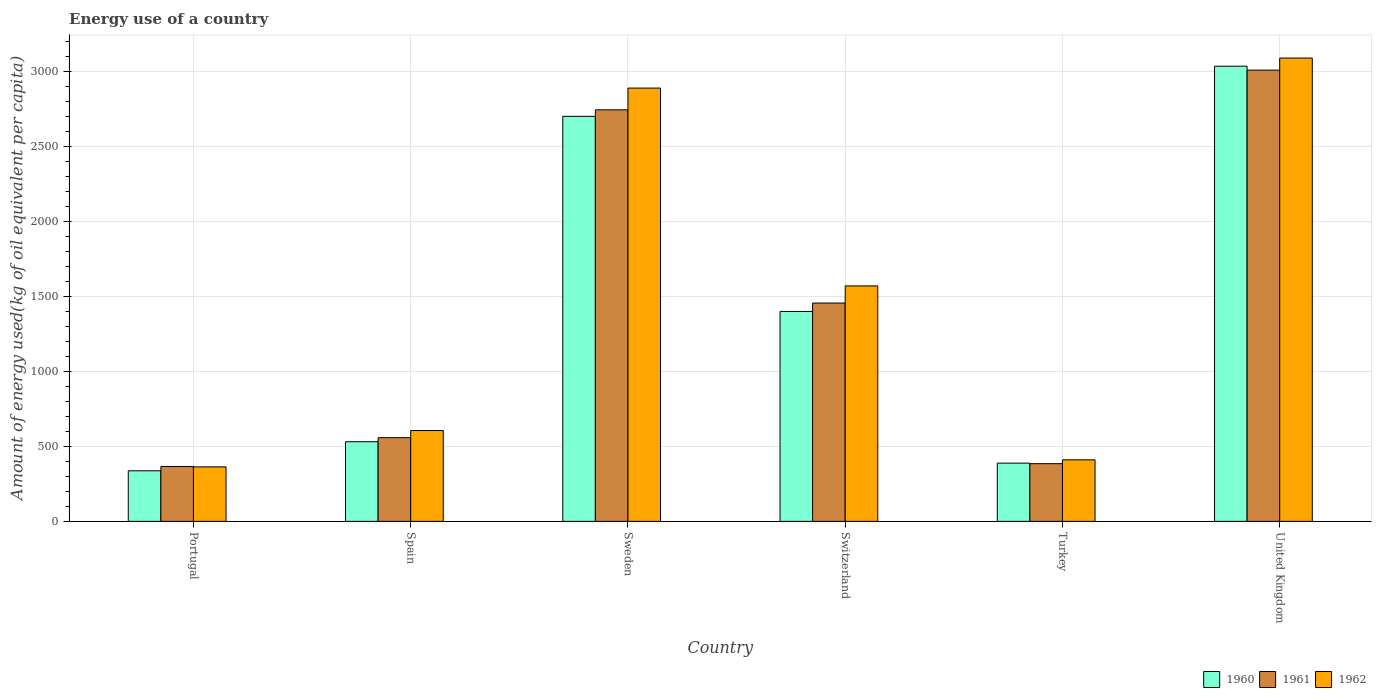How many different coloured bars are there?
Offer a very short reply. 3. How many groups of bars are there?
Your answer should be compact. 6. Are the number of bars on each tick of the X-axis equal?
Provide a succinct answer. Yes. What is the amount of energy used in in 1960 in Switzerland?
Provide a short and direct response. 1398.65. Across all countries, what is the maximum amount of energy used in in 1960?
Give a very brief answer. 3033.05. Across all countries, what is the minimum amount of energy used in in 1961?
Make the answer very short. 365.84. In which country was the amount of energy used in in 1960 maximum?
Your answer should be compact. United Kingdom. What is the total amount of energy used in in 1960 in the graph?
Offer a terse response. 8386.05. What is the difference between the amount of energy used in in 1962 in Spain and that in Switzerland?
Keep it short and to the point. -963.69. What is the difference between the amount of energy used in in 1960 in Switzerland and the amount of energy used in in 1961 in Sweden?
Ensure brevity in your answer.  -1343.47. What is the average amount of energy used in in 1961 per country?
Your response must be concise. 1418.57. What is the difference between the amount of energy used in of/in 1961 and amount of energy used in of/in 1960 in United Kingdom?
Provide a succinct answer. -26.3. In how many countries, is the amount of energy used in in 1960 greater than 100 kg?
Offer a terse response. 6. What is the ratio of the amount of energy used in in 1960 in Switzerland to that in United Kingdom?
Ensure brevity in your answer.  0.46. Is the amount of energy used in in 1961 in Spain less than that in Switzerland?
Provide a short and direct response. Yes. Is the difference between the amount of energy used in in 1961 in Spain and Switzerland greater than the difference between the amount of energy used in in 1960 in Spain and Switzerland?
Ensure brevity in your answer.  No. What is the difference between the highest and the second highest amount of energy used in in 1961?
Offer a terse response. -264.62. What is the difference between the highest and the lowest amount of energy used in in 1960?
Make the answer very short. 2696.14. How many bars are there?
Provide a short and direct response. 18. Are all the bars in the graph horizontal?
Your answer should be very brief. No. What is the difference between two consecutive major ticks on the Y-axis?
Provide a succinct answer. 500. Does the graph contain grids?
Make the answer very short. Yes. How many legend labels are there?
Offer a very short reply. 3. How are the legend labels stacked?
Provide a succinct answer. Horizontal. What is the title of the graph?
Ensure brevity in your answer.  Energy use of a country. What is the label or title of the X-axis?
Your answer should be compact. Country. What is the label or title of the Y-axis?
Make the answer very short. Amount of energy used(kg of oil equivalent per capita). What is the Amount of energy used(kg of oil equivalent per capita) in 1960 in Portugal?
Offer a very short reply. 336.91. What is the Amount of energy used(kg of oil equivalent per capita) in 1961 in Portugal?
Your response must be concise. 365.84. What is the Amount of energy used(kg of oil equivalent per capita) of 1962 in Portugal?
Your answer should be compact. 363.16. What is the Amount of energy used(kg of oil equivalent per capita) in 1960 in Spain?
Give a very brief answer. 530.66. What is the Amount of energy used(kg of oil equivalent per capita) of 1961 in Spain?
Keep it short and to the point. 557.6. What is the Amount of energy used(kg of oil equivalent per capita) in 1962 in Spain?
Provide a succinct answer. 605.22. What is the Amount of energy used(kg of oil equivalent per capita) of 1960 in Sweden?
Your answer should be compact. 2698.79. What is the Amount of energy used(kg of oil equivalent per capita) of 1961 in Sweden?
Your answer should be very brief. 2742.12. What is the Amount of energy used(kg of oil equivalent per capita) in 1962 in Sweden?
Give a very brief answer. 2887.24. What is the Amount of energy used(kg of oil equivalent per capita) in 1960 in Switzerland?
Ensure brevity in your answer.  1398.65. What is the Amount of energy used(kg of oil equivalent per capita) of 1961 in Switzerland?
Ensure brevity in your answer.  1454.76. What is the Amount of energy used(kg of oil equivalent per capita) of 1962 in Switzerland?
Offer a terse response. 1568.91. What is the Amount of energy used(kg of oil equivalent per capita) of 1960 in Turkey?
Ensure brevity in your answer.  387.97. What is the Amount of energy used(kg of oil equivalent per capita) in 1961 in Turkey?
Offer a terse response. 384.35. What is the Amount of energy used(kg of oil equivalent per capita) in 1962 in Turkey?
Offer a very short reply. 410.02. What is the Amount of energy used(kg of oil equivalent per capita) in 1960 in United Kingdom?
Your answer should be compact. 3033.05. What is the Amount of energy used(kg of oil equivalent per capita) of 1961 in United Kingdom?
Make the answer very short. 3006.75. What is the Amount of energy used(kg of oil equivalent per capita) in 1962 in United Kingdom?
Offer a terse response. 3087.34. Across all countries, what is the maximum Amount of energy used(kg of oil equivalent per capita) of 1960?
Keep it short and to the point. 3033.05. Across all countries, what is the maximum Amount of energy used(kg of oil equivalent per capita) in 1961?
Your answer should be very brief. 3006.75. Across all countries, what is the maximum Amount of energy used(kg of oil equivalent per capita) in 1962?
Give a very brief answer. 3087.34. Across all countries, what is the minimum Amount of energy used(kg of oil equivalent per capita) of 1960?
Provide a succinct answer. 336.91. Across all countries, what is the minimum Amount of energy used(kg of oil equivalent per capita) of 1961?
Provide a succinct answer. 365.84. Across all countries, what is the minimum Amount of energy used(kg of oil equivalent per capita) in 1962?
Your response must be concise. 363.16. What is the total Amount of energy used(kg of oil equivalent per capita) of 1960 in the graph?
Your answer should be very brief. 8386.05. What is the total Amount of energy used(kg of oil equivalent per capita) in 1961 in the graph?
Your answer should be very brief. 8511.41. What is the total Amount of energy used(kg of oil equivalent per capita) of 1962 in the graph?
Make the answer very short. 8921.9. What is the difference between the Amount of energy used(kg of oil equivalent per capita) of 1960 in Portugal and that in Spain?
Provide a succinct answer. -193.75. What is the difference between the Amount of energy used(kg of oil equivalent per capita) in 1961 in Portugal and that in Spain?
Your answer should be compact. -191.76. What is the difference between the Amount of energy used(kg of oil equivalent per capita) of 1962 in Portugal and that in Spain?
Make the answer very short. -242.06. What is the difference between the Amount of energy used(kg of oil equivalent per capita) of 1960 in Portugal and that in Sweden?
Give a very brief answer. -2361.88. What is the difference between the Amount of energy used(kg of oil equivalent per capita) of 1961 in Portugal and that in Sweden?
Ensure brevity in your answer.  -2376.28. What is the difference between the Amount of energy used(kg of oil equivalent per capita) of 1962 in Portugal and that in Sweden?
Ensure brevity in your answer.  -2524.07. What is the difference between the Amount of energy used(kg of oil equivalent per capita) in 1960 in Portugal and that in Switzerland?
Provide a short and direct response. -1061.74. What is the difference between the Amount of energy used(kg of oil equivalent per capita) in 1961 in Portugal and that in Switzerland?
Offer a very short reply. -1088.91. What is the difference between the Amount of energy used(kg of oil equivalent per capita) in 1962 in Portugal and that in Switzerland?
Your answer should be compact. -1205.75. What is the difference between the Amount of energy used(kg of oil equivalent per capita) in 1960 in Portugal and that in Turkey?
Provide a short and direct response. -51.06. What is the difference between the Amount of energy used(kg of oil equivalent per capita) of 1961 in Portugal and that in Turkey?
Offer a terse response. -18.51. What is the difference between the Amount of energy used(kg of oil equivalent per capita) of 1962 in Portugal and that in Turkey?
Offer a very short reply. -46.86. What is the difference between the Amount of energy used(kg of oil equivalent per capita) of 1960 in Portugal and that in United Kingdom?
Offer a very short reply. -2696.14. What is the difference between the Amount of energy used(kg of oil equivalent per capita) in 1961 in Portugal and that in United Kingdom?
Keep it short and to the point. -2640.91. What is the difference between the Amount of energy used(kg of oil equivalent per capita) in 1962 in Portugal and that in United Kingdom?
Give a very brief answer. -2724.18. What is the difference between the Amount of energy used(kg of oil equivalent per capita) in 1960 in Spain and that in Sweden?
Keep it short and to the point. -2168.13. What is the difference between the Amount of energy used(kg of oil equivalent per capita) of 1961 in Spain and that in Sweden?
Ensure brevity in your answer.  -2184.52. What is the difference between the Amount of energy used(kg of oil equivalent per capita) of 1962 in Spain and that in Sweden?
Provide a short and direct response. -2282.01. What is the difference between the Amount of energy used(kg of oil equivalent per capita) in 1960 in Spain and that in Switzerland?
Your response must be concise. -867.99. What is the difference between the Amount of energy used(kg of oil equivalent per capita) in 1961 in Spain and that in Switzerland?
Provide a succinct answer. -897.16. What is the difference between the Amount of energy used(kg of oil equivalent per capita) of 1962 in Spain and that in Switzerland?
Give a very brief answer. -963.69. What is the difference between the Amount of energy used(kg of oil equivalent per capita) in 1960 in Spain and that in Turkey?
Keep it short and to the point. 142.69. What is the difference between the Amount of energy used(kg of oil equivalent per capita) in 1961 in Spain and that in Turkey?
Your response must be concise. 173.25. What is the difference between the Amount of energy used(kg of oil equivalent per capita) in 1962 in Spain and that in Turkey?
Provide a succinct answer. 195.2. What is the difference between the Amount of energy used(kg of oil equivalent per capita) in 1960 in Spain and that in United Kingdom?
Provide a short and direct response. -2502.39. What is the difference between the Amount of energy used(kg of oil equivalent per capita) of 1961 in Spain and that in United Kingdom?
Your answer should be compact. -2449.15. What is the difference between the Amount of energy used(kg of oil equivalent per capita) of 1962 in Spain and that in United Kingdom?
Ensure brevity in your answer.  -2482.12. What is the difference between the Amount of energy used(kg of oil equivalent per capita) in 1960 in Sweden and that in Switzerland?
Make the answer very short. 1300.14. What is the difference between the Amount of energy used(kg of oil equivalent per capita) in 1961 in Sweden and that in Switzerland?
Your answer should be very brief. 1287.37. What is the difference between the Amount of energy used(kg of oil equivalent per capita) of 1962 in Sweden and that in Switzerland?
Ensure brevity in your answer.  1318.33. What is the difference between the Amount of energy used(kg of oil equivalent per capita) of 1960 in Sweden and that in Turkey?
Your answer should be compact. 2310.82. What is the difference between the Amount of energy used(kg of oil equivalent per capita) in 1961 in Sweden and that in Turkey?
Provide a succinct answer. 2357.78. What is the difference between the Amount of energy used(kg of oil equivalent per capita) in 1962 in Sweden and that in Turkey?
Your response must be concise. 2477.21. What is the difference between the Amount of energy used(kg of oil equivalent per capita) of 1960 in Sweden and that in United Kingdom?
Your answer should be very brief. -334.26. What is the difference between the Amount of energy used(kg of oil equivalent per capita) of 1961 in Sweden and that in United Kingdom?
Your answer should be compact. -264.62. What is the difference between the Amount of energy used(kg of oil equivalent per capita) in 1962 in Sweden and that in United Kingdom?
Your response must be concise. -200.11. What is the difference between the Amount of energy used(kg of oil equivalent per capita) of 1960 in Switzerland and that in Turkey?
Provide a succinct answer. 1010.68. What is the difference between the Amount of energy used(kg of oil equivalent per capita) in 1961 in Switzerland and that in Turkey?
Offer a terse response. 1070.41. What is the difference between the Amount of energy used(kg of oil equivalent per capita) of 1962 in Switzerland and that in Turkey?
Offer a very short reply. 1158.89. What is the difference between the Amount of energy used(kg of oil equivalent per capita) in 1960 in Switzerland and that in United Kingdom?
Ensure brevity in your answer.  -1634.4. What is the difference between the Amount of energy used(kg of oil equivalent per capita) in 1961 in Switzerland and that in United Kingdom?
Provide a short and direct response. -1551.99. What is the difference between the Amount of energy used(kg of oil equivalent per capita) of 1962 in Switzerland and that in United Kingdom?
Ensure brevity in your answer.  -1518.43. What is the difference between the Amount of energy used(kg of oil equivalent per capita) of 1960 in Turkey and that in United Kingdom?
Make the answer very short. -2645.08. What is the difference between the Amount of energy used(kg of oil equivalent per capita) of 1961 in Turkey and that in United Kingdom?
Provide a succinct answer. -2622.4. What is the difference between the Amount of energy used(kg of oil equivalent per capita) of 1962 in Turkey and that in United Kingdom?
Provide a short and direct response. -2677.32. What is the difference between the Amount of energy used(kg of oil equivalent per capita) in 1960 in Portugal and the Amount of energy used(kg of oil equivalent per capita) in 1961 in Spain?
Keep it short and to the point. -220.69. What is the difference between the Amount of energy used(kg of oil equivalent per capita) in 1960 in Portugal and the Amount of energy used(kg of oil equivalent per capita) in 1962 in Spain?
Ensure brevity in your answer.  -268.31. What is the difference between the Amount of energy used(kg of oil equivalent per capita) in 1961 in Portugal and the Amount of energy used(kg of oil equivalent per capita) in 1962 in Spain?
Ensure brevity in your answer.  -239.38. What is the difference between the Amount of energy used(kg of oil equivalent per capita) in 1960 in Portugal and the Amount of energy used(kg of oil equivalent per capita) in 1961 in Sweden?
Keep it short and to the point. -2405.21. What is the difference between the Amount of energy used(kg of oil equivalent per capita) in 1960 in Portugal and the Amount of energy used(kg of oil equivalent per capita) in 1962 in Sweden?
Keep it short and to the point. -2550.32. What is the difference between the Amount of energy used(kg of oil equivalent per capita) of 1961 in Portugal and the Amount of energy used(kg of oil equivalent per capita) of 1962 in Sweden?
Provide a short and direct response. -2521.4. What is the difference between the Amount of energy used(kg of oil equivalent per capita) in 1960 in Portugal and the Amount of energy used(kg of oil equivalent per capita) in 1961 in Switzerland?
Provide a succinct answer. -1117.84. What is the difference between the Amount of energy used(kg of oil equivalent per capita) in 1960 in Portugal and the Amount of energy used(kg of oil equivalent per capita) in 1962 in Switzerland?
Give a very brief answer. -1232. What is the difference between the Amount of energy used(kg of oil equivalent per capita) in 1961 in Portugal and the Amount of energy used(kg of oil equivalent per capita) in 1962 in Switzerland?
Ensure brevity in your answer.  -1203.07. What is the difference between the Amount of energy used(kg of oil equivalent per capita) of 1960 in Portugal and the Amount of energy used(kg of oil equivalent per capita) of 1961 in Turkey?
Offer a very short reply. -47.43. What is the difference between the Amount of energy used(kg of oil equivalent per capita) of 1960 in Portugal and the Amount of energy used(kg of oil equivalent per capita) of 1962 in Turkey?
Ensure brevity in your answer.  -73.11. What is the difference between the Amount of energy used(kg of oil equivalent per capita) in 1961 in Portugal and the Amount of energy used(kg of oil equivalent per capita) in 1962 in Turkey?
Provide a short and direct response. -44.18. What is the difference between the Amount of energy used(kg of oil equivalent per capita) in 1960 in Portugal and the Amount of energy used(kg of oil equivalent per capita) in 1961 in United Kingdom?
Provide a succinct answer. -2669.83. What is the difference between the Amount of energy used(kg of oil equivalent per capita) of 1960 in Portugal and the Amount of energy used(kg of oil equivalent per capita) of 1962 in United Kingdom?
Provide a short and direct response. -2750.43. What is the difference between the Amount of energy used(kg of oil equivalent per capita) in 1961 in Portugal and the Amount of energy used(kg of oil equivalent per capita) in 1962 in United Kingdom?
Provide a succinct answer. -2721.5. What is the difference between the Amount of energy used(kg of oil equivalent per capita) of 1960 in Spain and the Amount of energy used(kg of oil equivalent per capita) of 1961 in Sweden?
Provide a short and direct response. -2211.46. What is the difference between the Amount of energy used(kg of oil equivalent per capita) of 1960 in Spain and the Amount of energy used(kg of oil equivalent per capita) of 1962 in Sweden?
Give a very brief answer. -2356.57. What is the difference between the Amount of energy used(kg of oil equivalent per capita) of 1961 in Spain and the Amount of energy used(kg of oil equivalent per capita) of 1962 in Sweden?
Provide a succinct answer. -2329.64. What is the difference between the Amount of energy used(kg of oil equivalent per capita) of 1960 in Spain and the Amount of energy used(kg of oil equivalent per capita) of 1961 in Switzerland?
Make the answer very short. -924.09. What is the difference between the Amount of energy used(kg of oil equivalent per capita) in 1960 in Spain and the Amount of energy used(kg of oil equivalent per capita) in 1962 in Switzerland?
Offer a very short reply. -1038.25. What is the difference between the Amount of energy used(kg of oil equivalent per capita) of 1961 in Spain and the Amount of energy used(kg of oil equivalent per capita) of 1962 in Switzerland?
Provide a succinct answer. -1011.31. What is the difference between the Amount of energy used(kg of oil equivalent per capita) of 1960 in Spain and the Amount of energy used(kg of oil equivalent per capita) of 1961 in Turkey?
Offer a very short reply. 146.32. What is the difference between the Amount of energy used(kg of oil equivalent per capita) in 1960 in Spain and the Amount of energy used(kg of oil equivalent per capita) in 1962 in Turkey?
Your response must be concise. 120.64. What is the difference between the Amount of energy used(kg of oil equivalent per capita) of 1961 in Spain and the Amount of energy used(kg of oil equivalent per capita) of 1962 in Turkey?
Your response must be concise. 147.58. What is the difference between the Amount of energy used(kg of oil equivalent per capita) in 1960 in Spain and the Amount of energy used(kg of oil equivalent per capita) in 1961 in United Kingdom?
Offer a terse response. -2476.08. What is the difference between the Amount of energy used(kg of oil equivalent per capita) of 1960 in Spain and the Amount of energy used(kg of oil equivalent per capita) of 1962 in United Kingdom?
Make the answer very short. -2556.68. What is the difference between the Amount of energy used(kg of oil equivalent per capita) of 1961 in Spain and the Amount of energy used(kg of oil equivalent per capita) of 1962 in United Kingdom?
Provide a succinct answer. -2529.74. What is the difference between the Amount of energy used(kg of oil equivalent per capita) in 1960 in Sweden and the Amount of energy used(kg of oil equivalent per capita) in 1961 in Switzerland?
Your answer should be compact. 1244.04. What is the difference between the Amount of energy used(kg of oil equivalent per capita) of 1960 in Sweden and the Amount of energy used(kg of oil equivalent per capita) of 1962 in Switzerland?
Provide a succinct answer. 1129.88. What is the difference between the Amount of energy used(kg of oil equivalent per capita) of 1961 in Sweden and the Amount of energy used(kg of oil equivalent per capita) of 1962 in Switzerland?
Provide a short and direct response. 1173.21. What is the difference between the Amount of energy used(kg of oil equivalent per capita) in 1960 in Sweden and the Amount of energy used(kg of oil equivalent per capita) in 1961 in Turkey?
Keep it short and to the point. 2314.45. What is the difference between the Amount of energy used(kg of oil equivalent per capita) in 1960 in Sweden and the Amount of energy used(kg of oil equivalent per capita) in 1962 in Turkey?
Offer a terse response. 2288.77. What is the difference between the Amount of energy used(kg of oil equivalent per capita) in 1961 in Sweden and the Amount of energy used(kg of oil equivalent per capita) in 1962 in Turkey?
Offer a very short reply. 2332.1. What is the difference between the Amount of energy used(kg of oil equivalent per capita) in 1960 in Sweden and the Amount of energy used(kg of oil equivalent per capita) in 1961 in United Kingdom?
Ensure brevity in your answer.  -307.96. What is the difference between the Amount of energy used(kg of oil equivalent per capita) in 1960 in Sweden and the Amount of energy used(kg of oil equivalent per capita) in 1962 in United Kingdom?
Keep it short and to the point. -388.55. What is the difference between the Amount of energy used(kg of oil equivalent per capita) in 1961 in Sweden and the Amount of energy used(kg of oil equivalent per capita) in 1962 in United Kingdom?
Offer a very short reply. -345.22. What is the difference between the Amount of energy used(kg of oil equivalent per capita) in 1960 in Switzerland and the Amount of energy used(kg of oil equivalent per capita) in 1961 in Turkey?
Ensure brevity in your answer.  1014.31. What is the difference between the Amount of energy used(kg of oil equivalent per capita) in 1960 in Switzerland and the Amount of energy used(kg of oil equivalent per capita) in 1962 in Turkey?
Offer a very short reply. 988.63. What is the difference between the Amount of energy used(kg of oil equivalent per capita) of 1961 in Switzerland and the Amount of energy used(kg of oil equivalent per capita) of 1962 in Turkey?
Your response must be concise. 1044.73. What is the difference between the Amount of energy used(kg of oil equivalent per capita) of 1960 in Switzerland and the Amount of energy used(kg of oil equivalent per capita) of 1961 in United Kingdom?
Your response must be concise. -1608.09. What is the difference between the Amount of energy used(kg of oil equivalent per capita) of 1960 in Switzerland and the Amount of energy used(kg of oil equivalent per capita) of 1962 in United Kingdom?
Give a very brief answer. -1688.69. What is the difference between the Amount of energy used(kg of oil equivalent per capita) of 1961 in Switzerland and the Amount of energy used(kg of oil equivalent per capita) of 1962 in United Kingdom?
Offer a very short reply. -1632.59. What is the difference between the Amount of energy used(kg of oil equivalent per capita) of 1960 in Turkey and the Amount of energy used(kg of oil equivalent per capita) of 1961 in United Kingdom?
Your answer should be very brief. -2618.78. What is the difference between the Amount of energy used(kg of oil equivalent per capita) of 1960 in Turkey and the Amount of energy used(kg of oil equivalent per capita) of 1962 in United Kingdom?
Your answer should be compact. -2699.37. What is the difference between the Amount of energy used(kg of oil equivalent per capita) in 1961 in Turkey and the Amount of energy used(kg of oil equivalent per capita) in 1962 in United Kingdom?
Your answer should be compact. -2703. What is the average Amount of energy used(kg of oil equivalent per capita) of 1960 per country?
Make the answer very short. 1397.67. What is the average Amount of energy used(kg of oil equivalent per capita) of 1961 per country?
Your answer should be very brief. 1418.57. What is the average Amount of energy used(kg of oil equivalent per capita) of 1962 per country?
Your answer should be very brief. 1486.98. What is the difference between the Amount of energy used(kg of oil equivalent per capita) in 1960 and Amount of energy used(kg of oil equivalent per capita) in 1961 in Portugal?
Provide a succinct answer. -28.93. What is the difference between the Amount of energy used(kg of oil equivalent per capita) of 1960 and Amount of energy used(kg of oil equivalent per capita) of 1962 in Portugal?
Make the answer very short. -26.25. What is the difference between the Amount of energy used(kg of oil equivalent per capita) of 1961 and Amount of energy used(kg of oil equivalent per capita) of 1962 in Portugal?
Make the answer very short. 2.68. What is the difference between the Amount of energy used(kg of oil equivalent per capita) of 1960 and Amount of energy used(kg of oil equivalent per capita) of 1961 in Spain?
Provide a succinct answer. -26.93. What is the difference between the Amount of energy used(kg of oil equivalent per capita) in 1960 and Amount of energy used(kg of oil equivalent per capita) in 1962 in Spain?
Offer a terse response. -74.56. What is the difference between the Amount of energy used(kg of oil equivalent per capita) of 1961 and Amount of energy used(kg of oil equivalent per capita) of 1962 in Spain?
Offer a terse response. -47.62. What is the difference between the Amount of energy used(kg of oil equivalent per capita) in 1960 and Amount of energy used(kg of oil equivalent per capita) in 1961 in Sweden?
Keep it short and to the point. -43.33. What is the difference between the Amount of energy used(kg of oil equivalent per capita) of 1960 and Amount of energy used(kg of oil equivalent per capita) of 1962 in Sweden?
Offer a terse response. -188.44. What is the difference between the Amount of energy used(kg of oil equivalent per capita) in 1961 and Amount of energy used(kg of oil equivalent per capita) in 1962 in Sweden?
Keep it short and to the point. -145.11. What is the difference between the Amount of energy used(kg of oil equivalent per capita) in 1960 and Amount of energy used(kg of oil equivalent per capita) in 1961 in Switzerland?
Make the answer very short. -56.1. What is the difference between the Amount of energy used(kg of oil equivalent per capita) in 1960 and Amount of energy used(kg of oil equivalent per capita) in 1962 in Switzerland?
Offer a very short reply. -170.26. What is the difference between the Amount of energy used(kg of oil equivalent per capita) of 1961 and Amount of energy used(kg of oil equivalent per capita) of 1962 in Switzerland?
Give a very brief answer. -114.16. What is the difference between the Amount of energy used(kg of oil equivalent per capita) in 1960 and Amount of energy used(kg of oil equivalent per capita) in 1961 in Turkey?
Provide a short and direct response. 3.62. What is the difference between the Amount of energy used(kg of oil equivalent per capita) of 1960 and Amount of energy used(kg of oil equivalent per capita) of 1962 in Turkey?
Offer a terse response. -22.05. What is the difference between the Amount of energy used(kg of oil equivalent per capita) in 1961 and Amount of energy used(kg of oil equivalent per capita) in 1962 in Turkey?
Provide a short and direct response. -25.68. What is the difference between the Amount of energy used(kg of oil equivalent per capita) of 1960 and Amount of energy used(kg of oil equivalent per capita) of 1961 in United Kingdom?
Your answer should be compact. 26.3. What is the difference between the Amount of energy used(kg of oil equivalent per capita) of 1960 and Amount of energy used(kg of oil equivalent per capita) of 1962 in United Kingdom?
Your answer should be compact. -54.29. What is the difference between the Amount of energy used(kg of oil equivalent per capita) in 1961 and Amount of energy used(kg of oil equivalent per capita) in 1962 in United Kingdom?
Offer a very short reply. -80.59. What is the ratio of the Amount of energy used(kg of oil equivalent per capita) of 1960 in Portugal to that in Spain?
Make the answer very short. 0.63. What is the ratio of the Amount of energy used(kg of oil equivalent per capita) in 1961 in Portugal to that in Spain?
Offer a very short reply. 0.66. What is the ratio of the Amount of energy used(kg of oil equivalent per capita) in 1962 in Portugal to that in Spain?
Your answer should be very brief. 0.6. What is the ratio of the Amount of energy used(kg of oil equivalent per capita) of 1960 in Portugal to that in Sweden?
Your answer should be compact. 0.12. What is the ratio of the Amount of energy used(kg of oil equivalent per capita) of 1961 in Portugal to that in Sweden?
Give a very brief answer. 0.13. What is the ratio of the Amount of energy used(kg of oil equivalent per capita) of 1962 in Portugal to that in Sweden?
Keep it short and to the point. 0.13. What is the ratio of the Amount of energy used(kg of oil equivalent per capita) of 1960 in Portugal to that in Switzerland?
Offer a very short reply. 0.24. What is the ratio of the Amount of energy used(kg of oil equivalent per capita) in 1961 in Portugal to that in Switzerland?
Ensure brevity in your answer.  0.25. What is the ratio of the Amount of energy used(kg of oil equivalent per capita) in 1962 in Portugal to that in Switzerland?
Your answer should be very brief. 0.23. What is the ratio of the Amount of energy used(kg of oil equivalent per capita) of 1960 in Portugal to that in Turkey?
Your answer should be compact. 0.87. What is the ratio of the Amount of energy used(kg of oil equivalent per capita) of 1961 in Portugal to that in Turkey?
Ensure brevity in your answer.  0.95. What is the ratio of the Amount of energy used(kg of oil equivalent per capita) in 1962 in Portugal to that in Turkey?
Make the answer very short. 0.89. What is the ratio of the Amount of energy used(kg of oil equivalent per capita) in 1960 in Portugal to that in United Kingdom?
Make the answer very short. 0.11. What is the ratio of the Amount of energy used(kg of oil equivalent per capita) of 1961 in Portugal to that in United Kingdom?
Your response must be concise. 0.12. What is the ratio of the Amount of energy used(kg of oil equivalent per capita) of 1962 in Portugal to that in United Kingdom?
Give a very brief answer. 0.12. What is the ratio of the Amount of energy used(kg of oil equivalent per capita) in 1960 in Spain to that in Sweden?
Your response must be concise. 0.2. What is the ratio of the Amount of energy used(kg of oil equivalent per capita) in 1961 in Spain to that in Sweden?
Offer a terse response. 0.2. What is the ratio of the Amount of energy used(kg of oil equivalent per capita) in 1962 in Spain to that in Sweden?
Your response must be concise. 0.21. What is the ratio of the Amount of energy used(kg of oil equivalent per capita) of 1960 in Spain to that in Switzerland?
Keep it short and to the point. 0.38. What is the ratio of the Amount of energy used(kg of oil equivalent per capita) in 1961 in Spain to that in Switzerland?
Your answer should be very brief. 0.38. What is the ratio of the Amount of energy used(kg of oil equivalent per capita) in 1962 in Spain to that in Switzerland?
Ensure brevity in your answer.  0.39. What is the ratio of the Amount of energy used(kg of oil equivalent per capita) in 1960 in Spain to that in Turkey?
Provide a short and direct response. 1.37. What is the ratio of the Amount of energy used(kg of oil equivalent per capita) of 1961 in Spain to that in Turkey?
Give a very brief answer. 1.45. What is the ratio of the Amount of energy used(kg of oil equivalent per capita) in 1962 in Spain to that in Turkey?
Your answer should be very brief. 1.48. What is the ratio of the Amount of energy used(kg of oil equivalent per capita) of 1960 in Spain to that in United Kingdom?
Ensure brevity in your answer.  0.17. What is the ratio of the Amount of energy used(kg of oil equivalent per capita) in 1961 in Spain to that in United Kingdom?
Make the answer very short. 0.19. What is the ratio of the Amount of energy used(kg of oil equivalent per capita) of 1962 in Spain to that in United Kingdom?
Your response must be concise. 0.2. What is the ratio of the Amount of energy used(kg of oil equivalent per capita) in 1960 in Sweden to that in Switzerland?
Your response must be concise. 1.93. What is the ratio of the Amount of energy used(kg of oil equivalent per capita) of 1961 in Sweden to that in Switzerland?
Provide a succinct answer. 1.88. What is the ratio of the Amount of energy used(kg of oil equivalent per capita) of 1962 in Sweden to that in Switzerland?
Keep it short and to the point. 1.84. What is the ratio of the Amount of energy used(kg of oil equivalent per capita) of 1960 in Sweden to that in Turkey?
Keep it short and to the point. 6.96. What is the ratio of the Amount of energy used(kg of oil equivalent per capita) of 1961 in Sweden to that in Turkey?
Offer a terse response. 7.13. What is the ratio of the Amount of energy used(kg of oil equivalent per capita) of 1962 in Sweden to that in Turkey?
Provide a succinct answer. 7.04. What is the ratio of the Amount of energy used(kg of oil equivalent per capita) in 1960 in Sweden to that in United Kingdom?
Your response must be concise. 0.89. What is the ratio of the Amount of energy used(kg of oil equivalent per capita) in 1961 in Sweden to that in United Kingdom?
Ensure brevity in your answer.  0.91. What is the ratio of the Amount of energy used(kg of oil equivalent per capita) of 1962 in Sweden to that in United Kingdom?
Your answer should be compact. 0.94. What is the ratio of the Amount of energy used(kg of oil equivalent per capita) of 1960 in Switzerland to that in Turkey?
Keep it short and to the point. 3.61. What is the ratio of the Amount of energy used(kg of oil equivalent per capita) of 1961 in Switzerland to that in Turkey?
Your response must be concise. 3.79. What is the ratio of the Amount of energy used(kg of oil equivalent per capita) of 1962 in Switzerland to that in Turkey?
Ensure brevity in your answer.  3.83. What is the ratio of the Amount of energy used(kg of oil equivalent per capita) of 1960 in Switzerland to that in United Kingdom?
Keep it short and to the point. 0.46. What is the ratio of the Amount of energy used(kg of oil equivalent per capita) of 1961 in Switzerland to that in United Kingdom?
Ensure brevity in your answer.  0.48. What is the ratio of the Amount of energy used(kg of oil equivalent per capita) in 1962 in Switzerland to that in United Kingdom?
Keep it short and to the point. 0.51. What is the ratio of the Amount of energy used(kg of oil equivalent per capita) in 1960 in Turkey to that in United Kingdom?
Your answer should be very brief. 0.13. What is the ratio of the Amount of energy used(kg of oil equivalent per capita) in 1961 in Turkey to that in United Kingdom?
Give a very brief answer. 0.13. What is the ratio of the Amount of energy used(kg of oil equivalent per capita) in 1962 in Turkey to that in United Kingdom?
Make the answer very short. 0.13. What is the difference between the highest and the second highest Amount of energy used(kg of oil equivalent per capita) of 1960?
Give a very brief answer. 334.26. What is the difference between the highest and the second highest Amount of energy used(kg of oil equivalent per capita) in 1961?
Keep it short and to the point. 264.62. What is the difference between the highest and the second highest Amount of energy used(kg of oil equivalent per capita) of 1962?
Offer a very short reply. 200.11. What is the difference between the highest and the lowest Amount of energy used(kg of oil equivalent per capita) of 1960?
Give a very brief answer. 2696.14. What is the difference between the highest and the lowest Amount of energy used(kg of oil equivalent per capita) of 1961?
Ensure brevity in your answer.  2640.91. What is the difference between the highest and the lowest Amount of energy used(kg of oil equivalent per capita) of 1962?
Provide a short and direct response. 2724.18. 